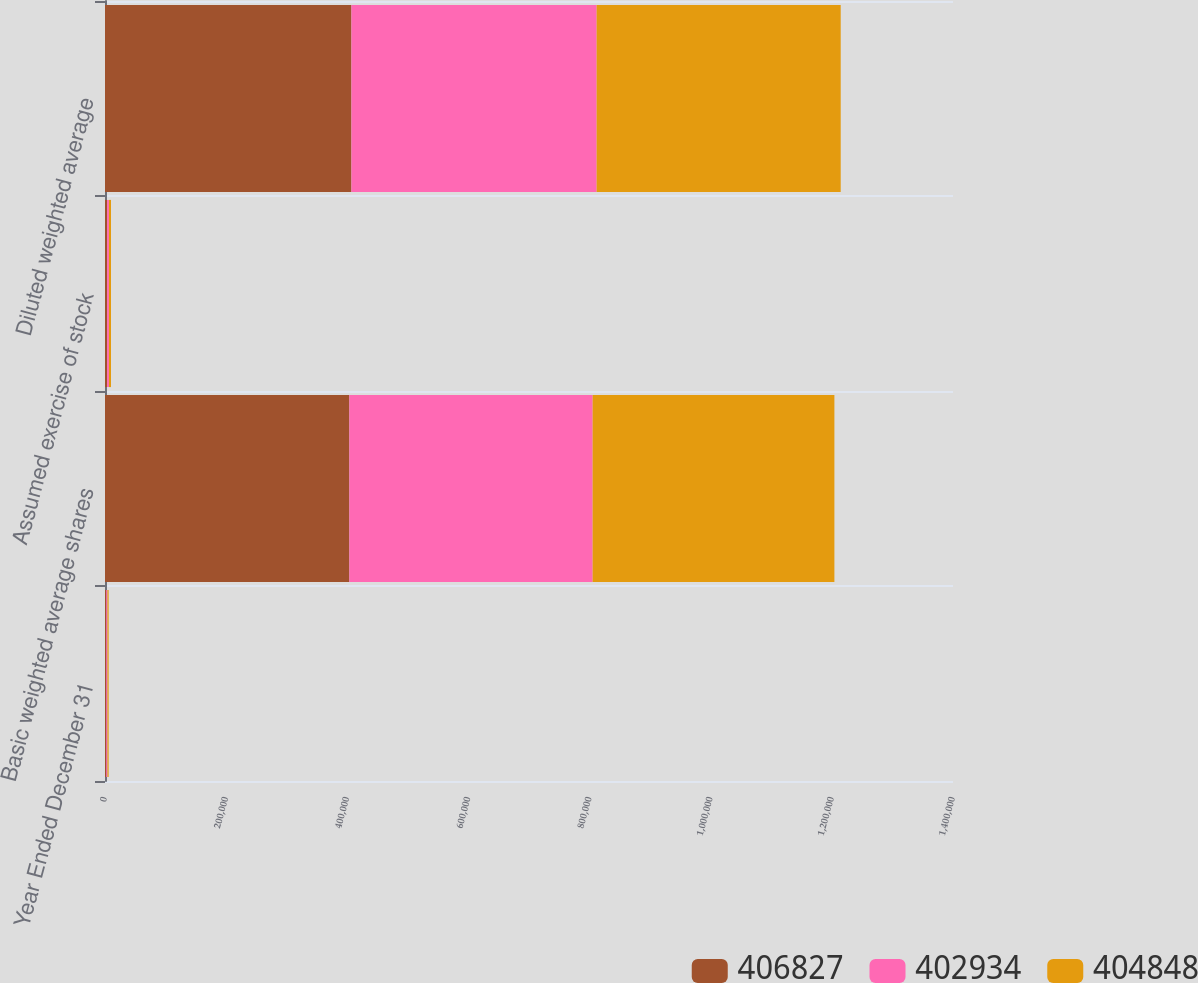Convert chart. <chart><loc_0><loc_0><loc_500><loc_500><stacked_bar_chart><ecel><fcel>Year Ended December 31<fcel>Basic weighted average shares<fcel>Assumed exercise of stock<fcel>Diluted weighted average<nl><fcel>406827<fcel>2006<fcel>403424<fcel>3403<fcel>406827<nl><fcel>402934<fcel>2005<fcel>401637<fcel>3110<fcel>404848<nl><fcel>404848<fcel>2004<fcel>399126<fcel>3404<fcel>402934<nl></chart> 